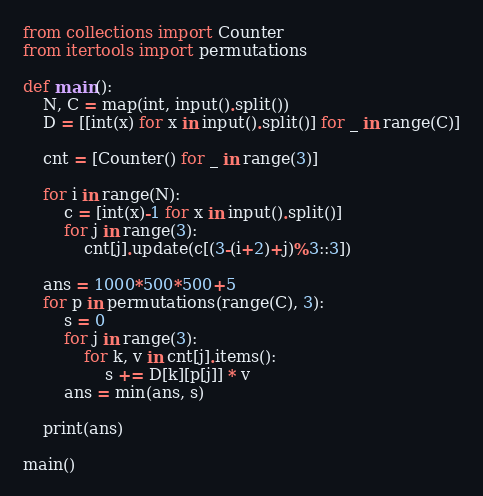Convert code to text. <code><loc_0><loc_0><loc_500><loc_500><_Python_>from collections import Counter
from itertools import permutations

def main():
    N, C = map(int, input().split())
    D = [[int(x) for x in input().split()] for _ in range(C)]

    cnt = [Counter() for _ in range(3)]

    for i in range(N):
        c = [int(x)-1 for x in input().split()]
        for j in range(3):
            cnt[j].update(c[(3-(i+2)+j)%3::3])

    ans = 1000*500*500+5
    for p in permutations(range(C), 3):
        s = 0
        for j in range(3):
            for k, v in cnt[j].items():
                s += D[k][p[j]] * v
        ans = min(ans, s)

    print(ans)

main()</code> 